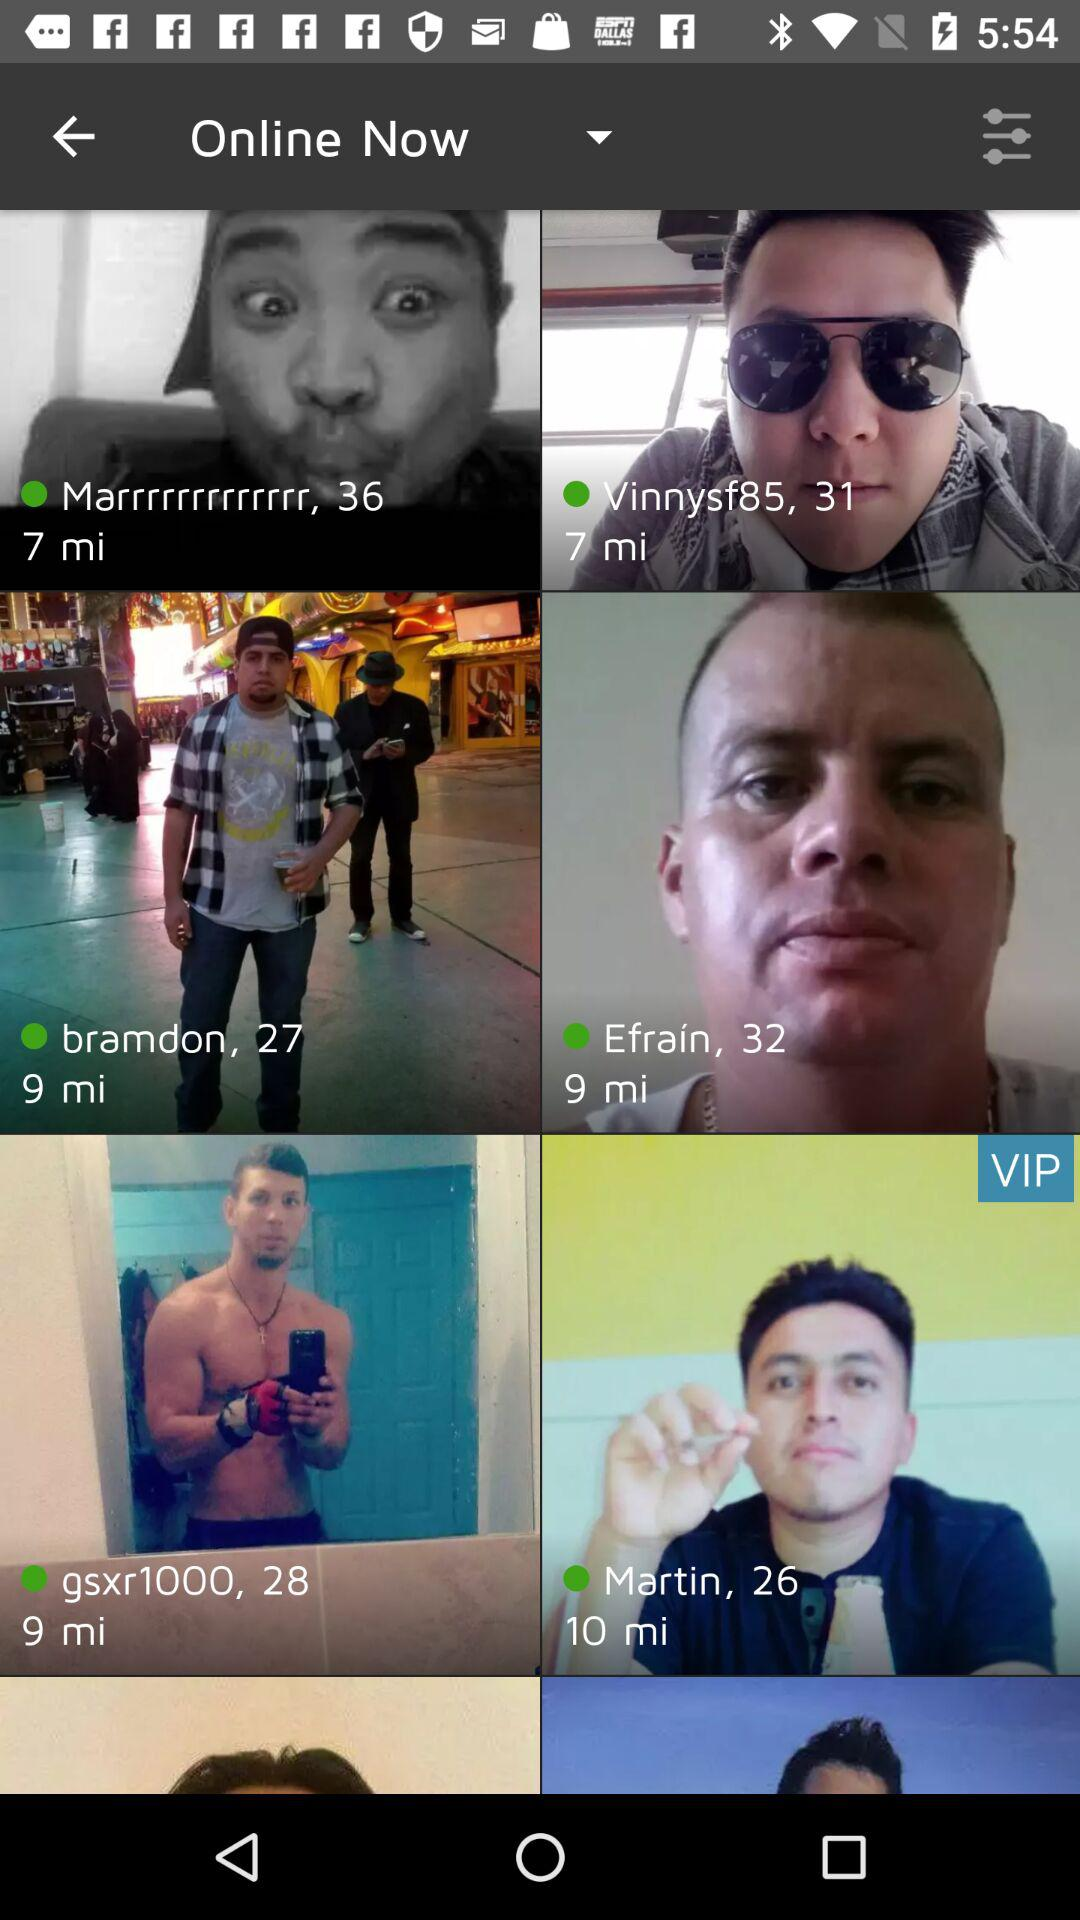What is the age of "Vinnysf85"? The age is 31 years. 